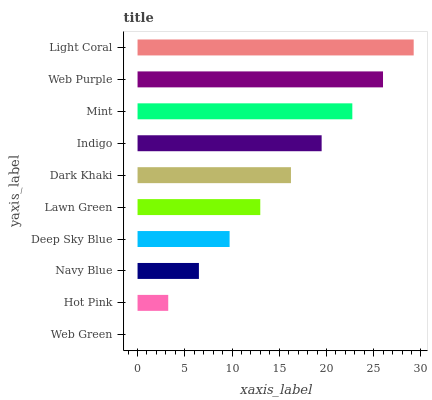Is Web Green the minimum?
Answer yes or no. Yes. Is Light Coral the maximum?
Answer yes or no. Yes. Is Hot Pink the minimum?
Answer yes or no. No. Is Hot Pink the maximum?
Answer yes or no. No. Is Hot Pink greater than Web Green?
Answer yes or no. Yes. Is Web Green less than Hot Pink?
Answer yes or no. Yes. Is Web Green greater than Hot Pink?
Answer yes or no. No. Is Hot Pink less than Web Green?
Answer yes or no. No. Is Dark Khaki the high median?
Answer yes or no. Yes. Is Lawn Green the low median?
Answer yes or no. Yes. Is Lawn Green the high median?
Answer yes or no. No. Is Web Purple the low median?
Answer yes or no. No. 